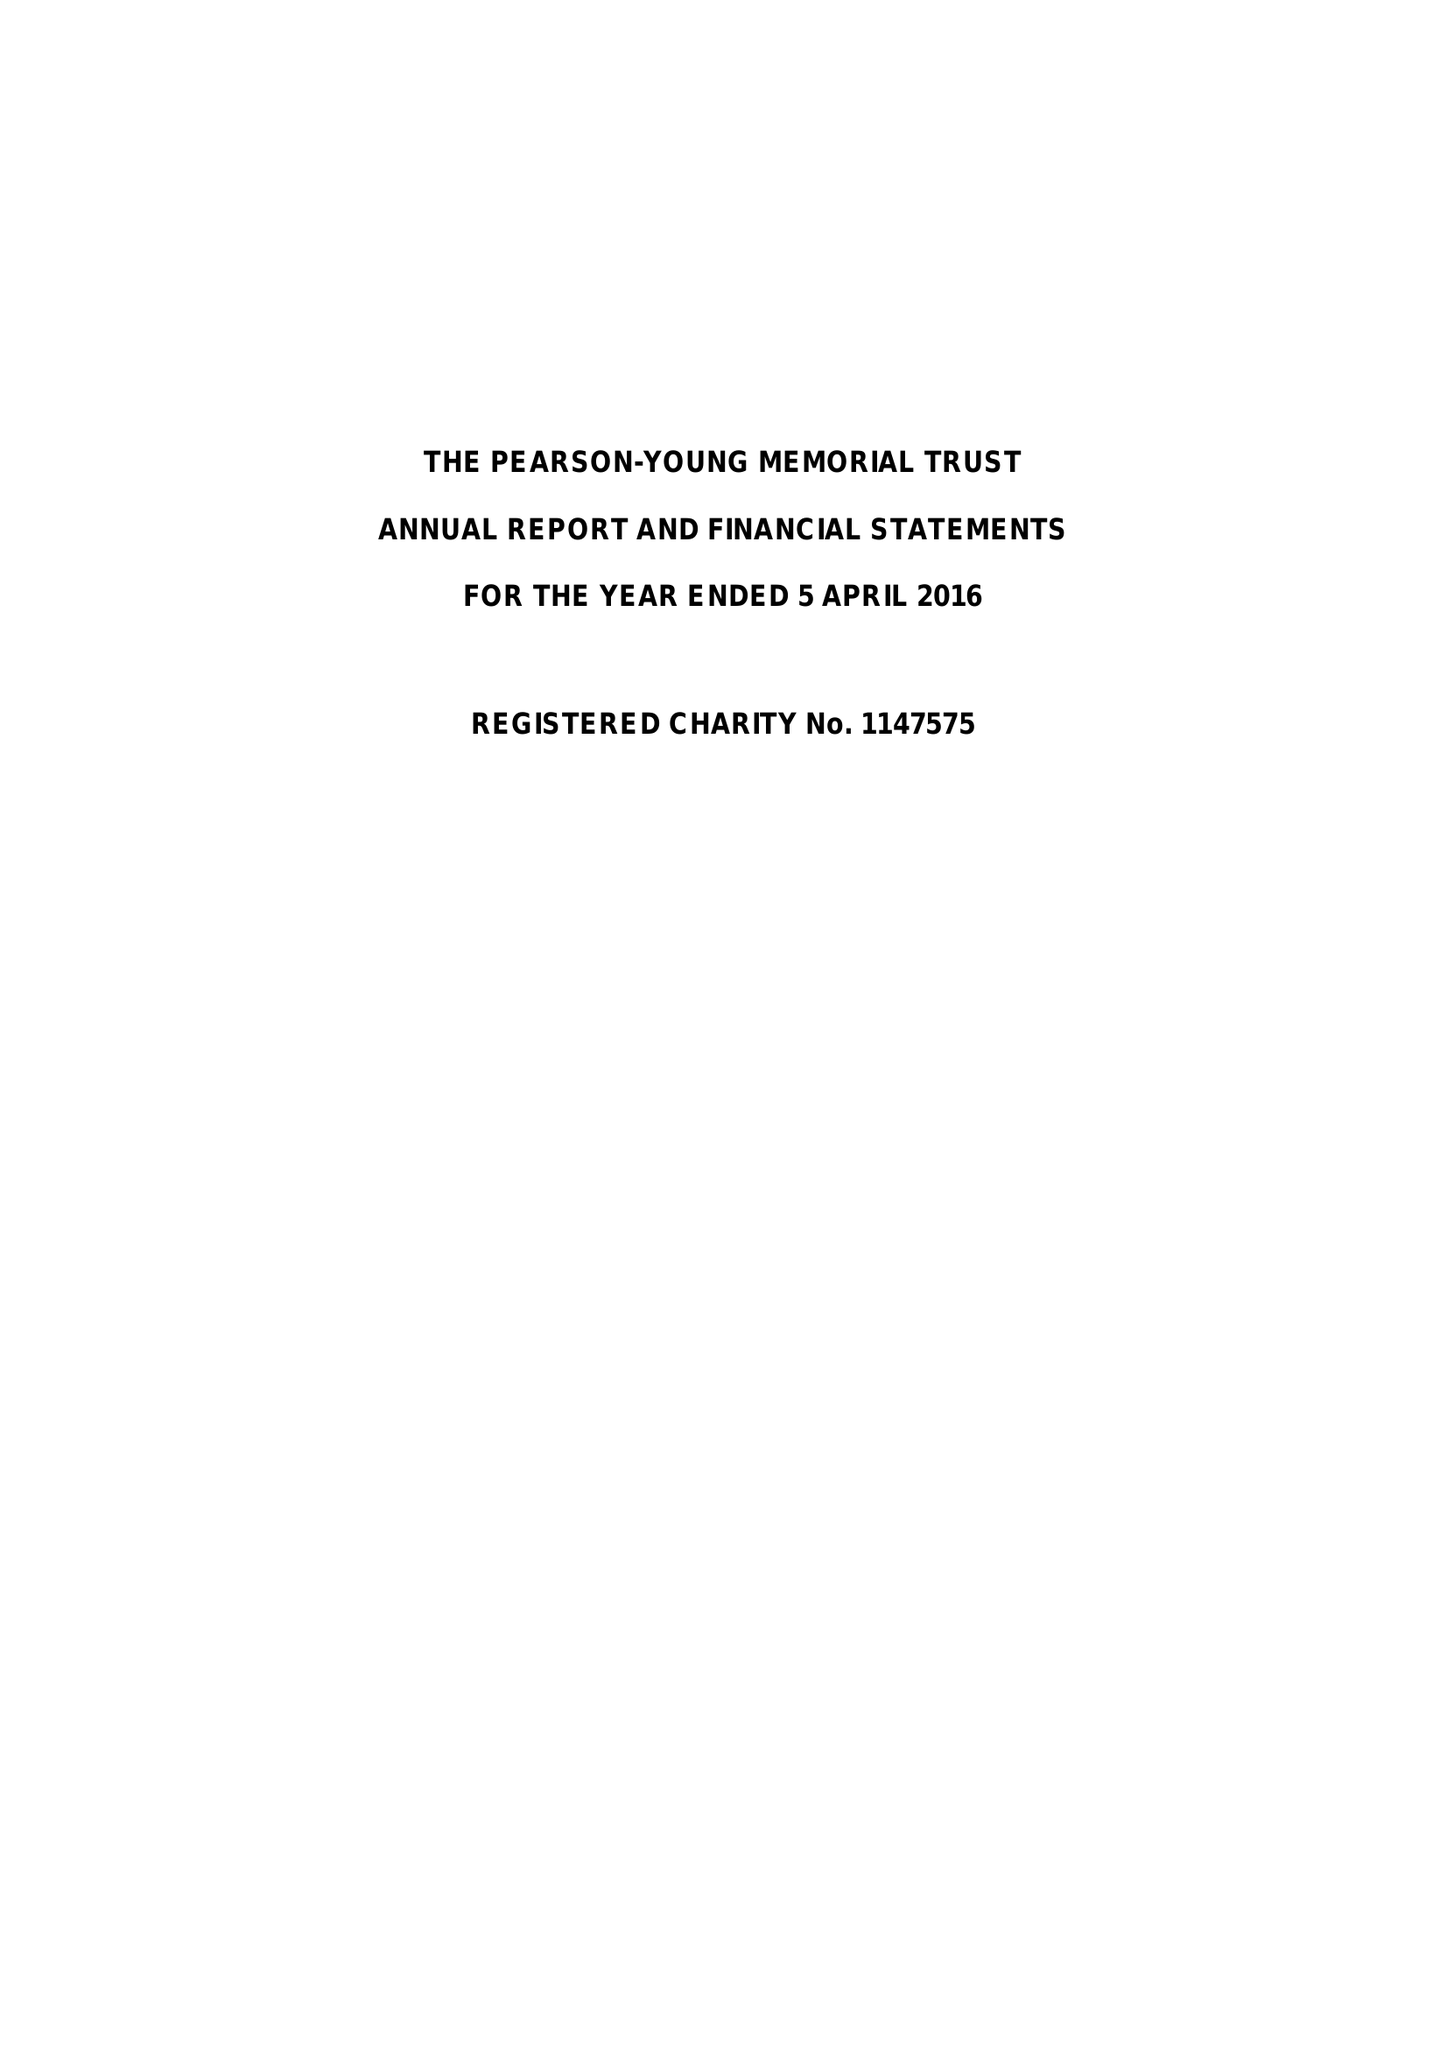What is the value for the report_date?
Answer the question using a single word or phrase. 2016-04-05 